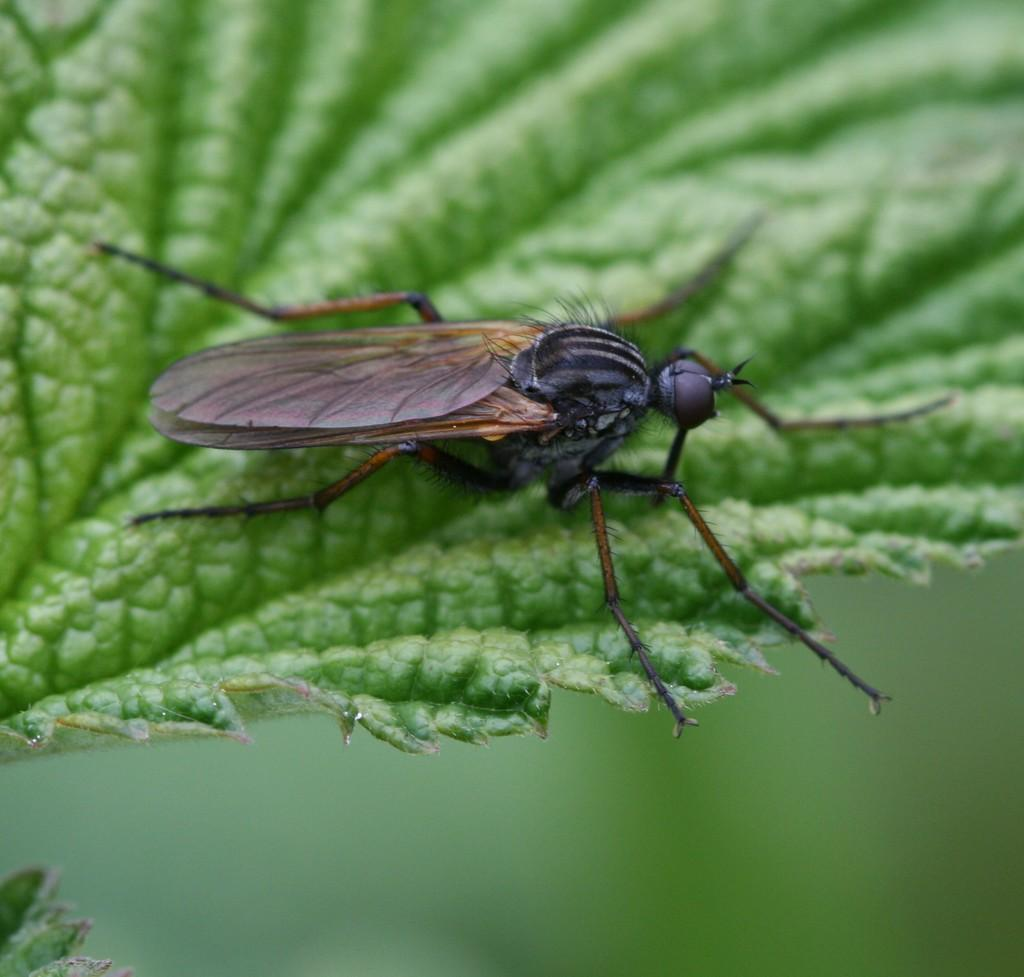What is present on the leaf in the image? There is an insect on the leaf in the image. Can you describe the insect's location on the leaf? The insect is on the leaf in the image. What type of chalk is the insect using to write on the leaf in the image? There is no chalk present in the image, and insects do not have the ability to write. 